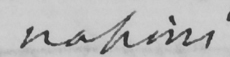Please transcribe the handwritten text in this image. nations 